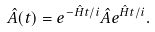Convert formula to latex. <formula><loc_0><loc_0><loc_500><loc_500>\hat { A } ( t ) = e ^ { - \hat { H } t / i } \hat { A } e ^ { \hat { H } t / i } .</formula> 